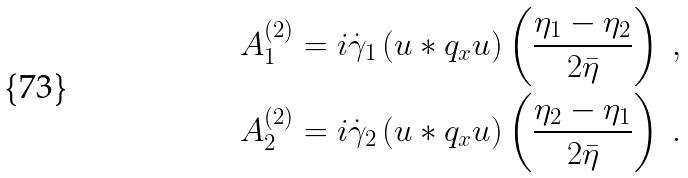<formula> <loc_0><loc_0><loc_500><loc_500>A _ { 1 } ^ { ( 2 ) } = i \dot { \gamma } _ { 1 } \left ( u \ast q _ { x } u \right ) \left ( \frac { \eta _ { 1 } - \eta _ { 2 } } { 2 \bar { \eta } } \right ) \ , \\ A _ { 2 } ^ { ( 2 ) } = i \dot { \gamma } _ { 2 } \left ( u \ast q _ { x } u \right ) \left ( \frac { \eta _ { 2 } - \eta _ { 1 } } { 2 \bar { \eta } } \right ) \ .</formula> 